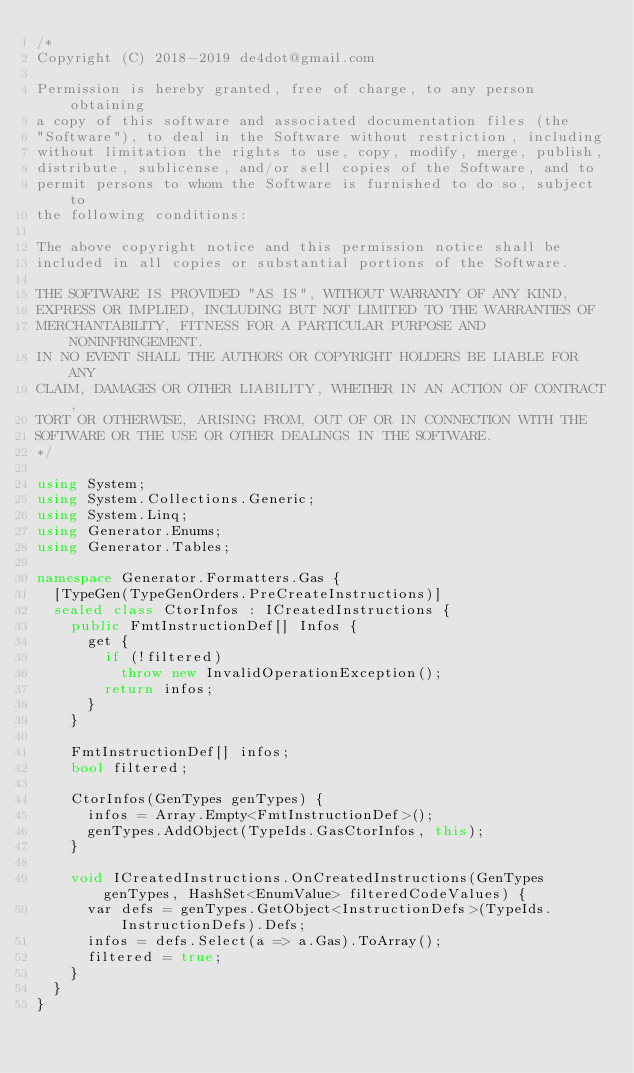<code> <loc_0><loc_0><loc_500><loc_500><_C#_>/*
Copyright (C) 2018-2019 de4dot@gmail.com

Permission is hereby granted, free of charge, to any person obtaining
a copy of this software and associated documentation files (the
"Software"), to deal in the Software without restriction, including
without limitation the rights to use, copy, modify, merge, publish,
distribute, sublicense, and/or sell copies of the Software, and to
permit persons to whom the Software is furnished to do so, subject to
the following conditions:

The above copyright notice and this permission notice shall be
included in all copies or substantial portions of the Software.

THE SOFTWARE IS PROVIDED "AS IS", WITHOUT WARRANTY OF ANY KIND,
EXPRESS OR IMPLIED, INCLUDING BUT NOT LIMITED TO THE WARRANTIES OF
MERCHANTABILITY, FITNESS FOR A PARTICULAR PURPOSE AND NONINFRINGEMENT.
IN NO EVENT SHALL THE AUTHORS OR COPYRIGHT HOLDERS BE LIABLE FOR ANY
CLAIM, DAMAGES OR OTHER LIABILITY, WHETHER IN AN ACTION OF CONTRACT,
TORT OR OTHERWISE, ARISING FROM, OUT OF OR IN CONNECTION WITH THE
SOFTWARE OR THE USE OR OTHER DEALINGS IN THE SOFTWARE.
*/

using System;
using System.Collections.Generic;
using System.Linq;
using Generator.Enums;
using Generator.Tables;

namespace Generator.Formatters.Gas {
	[TypeGen(TypeGenOrders.PreCreateInstructions)]
	sealed class CtorInfos : ICreatedInstructions {
		public FmtInstructionDef[] Infos {
			get {
				if (!filtered)
					throw new InvalidOperationException();
				return infos;
			}
		}

		FmtInstructionDef[] infos;
		bool filtered;

		CtorInfos(GenTypes genTypes) {
			infos = Array.Empty<FmtInstructionDef>();
			genTypes.AddObject(TypeIds.GasCtorInfos, this);
		}

		void ICreatedInstructions.OnCreatedInstructions(GenTypes genTypes, HashSet<EnumValue> filteredCodeValues) {
			var defs = genTypes.GetObject<InstructionDefs>(TypeIds.InstructionDefs).Defs;
			infos = defs.Select(a => a.Gas).ToArray();
			filtered = true;
		}
	}
}
</code> 